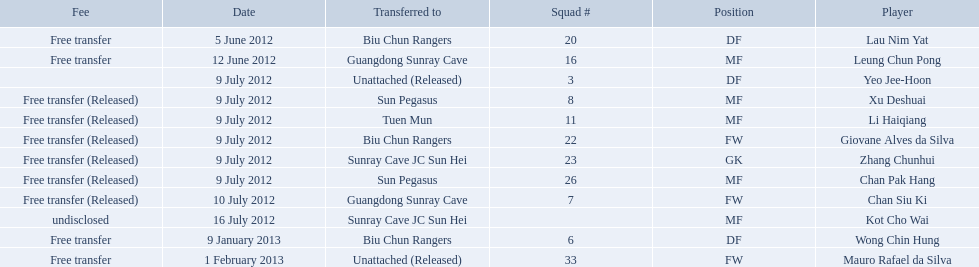On what dates were there non released free transfers? 5 June 2012, 12 June 2012, 9 January 2013, 1 February 2013. On which of these were the players transferred to another team? 5 June 2012, 12 June 2012, 9 January 2013. Which of these were the transfers to biu chun rangers? 5 June 2012, 9 January 2013. Parse the full table in json format. {'header': ['Fee', 'Date', 'Transferred to', 'Squad #', 'Position', 'Player'], 'rows': [['Free transfer', '5 June 2012', 'Biu Chun Rangers', '20', 'DF', 'Lau Nim Yat'], ['Free transfer', '12 June 2012', 'Guangdong Sunray Cave', '16', 'MF', 'Leung Chun Pong'], ['', '9 July 2012', 'Unattached (Released)', '3', 'DF', 'Yeo Jee-Hoon'], ['Free transfer (Released)', '9 July 2012', 'Sun Pegasus', '8', 'MF', 'Xu Deshuai'], ['Free transfer (Released)', '9 July 2012', 'Tuen Mun', '11', 'MF', 'Li Haiqiang'], ['Free transfer (Released)', '9 July 2012', 'Biu Chun Rangers', '22', 'FW', 'Giovane Alves da Silva'], ['Free transfer (Released)', '9 July 2012', 'Sunray Cave JC Sun Hei', '23', 'GK', 'Zhang Chunhui'], ['Free transfer (Released)', '9 July 2012', 'Sun Pegasus', '26', 'MF', 'Chan Pak Hang'], ['Free transfer (Released)', '10 July 2012', 'Guangdong Sunray Cave', '7', 'FW', 'Chan Siu Ki'], ['undisclosed', '16 July 2012', 'Sunray Cave JC Sun Hei', '', 'MF', 'Kot Cho Wai'], ['Free transfer', '9 January 2013', 'Biu Chun Rangers', '6', 'DF', 'Wong Chin Hung'], ['Free transfer', '1 February 2013', 'Unattached (Released)', '33', 'FW', 'Mauro Rafael da Silva']]} On which of those dated did they receive a df? 9 January 2013. 